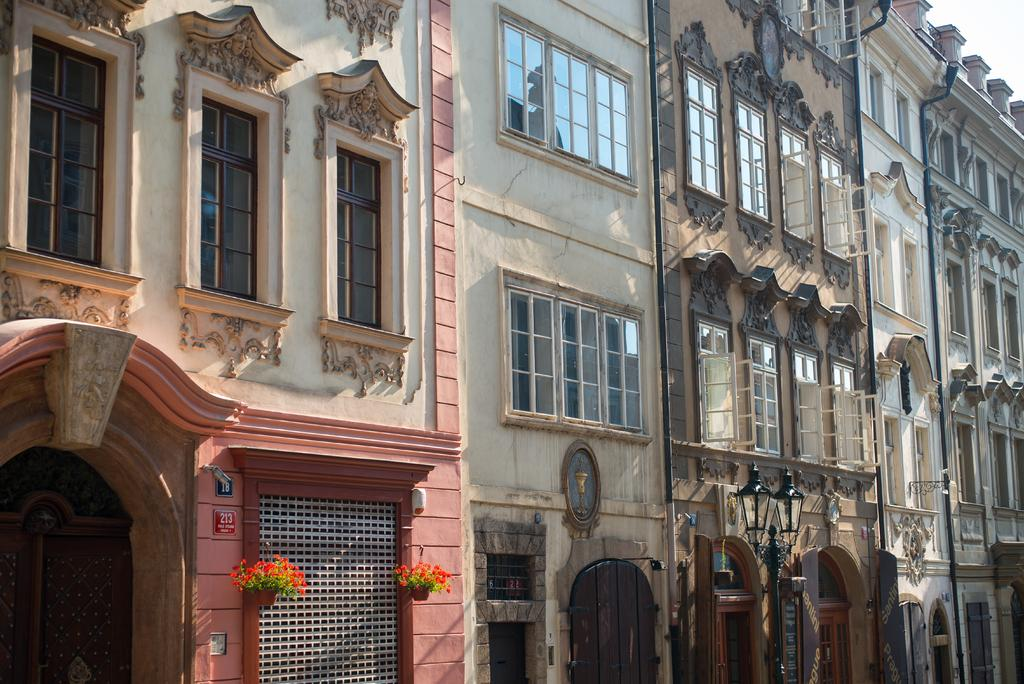What type of structures are visible in the image? There are many buildings in the image. What features can be seen on the buildings? The buildings have windows and doors. Can you describe any additional details about the buildings? There are two potted plants hanging on the wall in the front of the image. What is visible at the top of the image? The sky is visible at the top of the image. How many parcels are being transported by the seed in the image? There are no parcels or seeds present in the image. What type of seed is responsible for the transportation of parcels in the image? There is no seed or transportation of parcels in the image. 